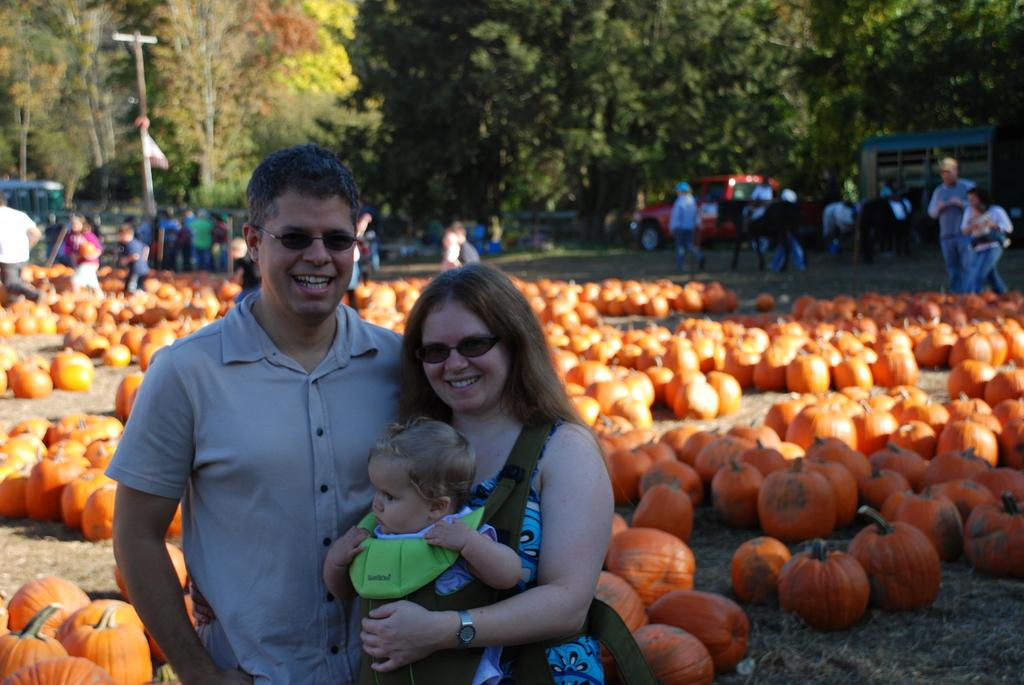What is placed on the ground in the image? There are fruits placed on the ground in the image. What are the people in the image doing? The people are standing around the fruits and taking pictures. What type of pen is being used to draw the frog in the image? There is no pen or frog present in the image; it features fruits on the ground and people taking pictures. 